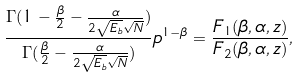<formula> <loc_0><loc_0><loc_500><loc_500>\frac { \Gamma ( 1 - \frac { \beta } { 2 } - \frac { \alpha } { 2 \sqrt { E _ { b } } \sqrt { N } } ) } { \Gamma ( \frac { \beta } { 2 } - \frac { \alpha } { 2 \sqrt { E _ { b } } \sqrt { N } } ) } p ^ { 1 - \beta } = \frac { F _ { 1 } ( \beta , \alpha , z ) } { F _ { 2 } ( \beta , \alpha , z ) } ,</formula> 